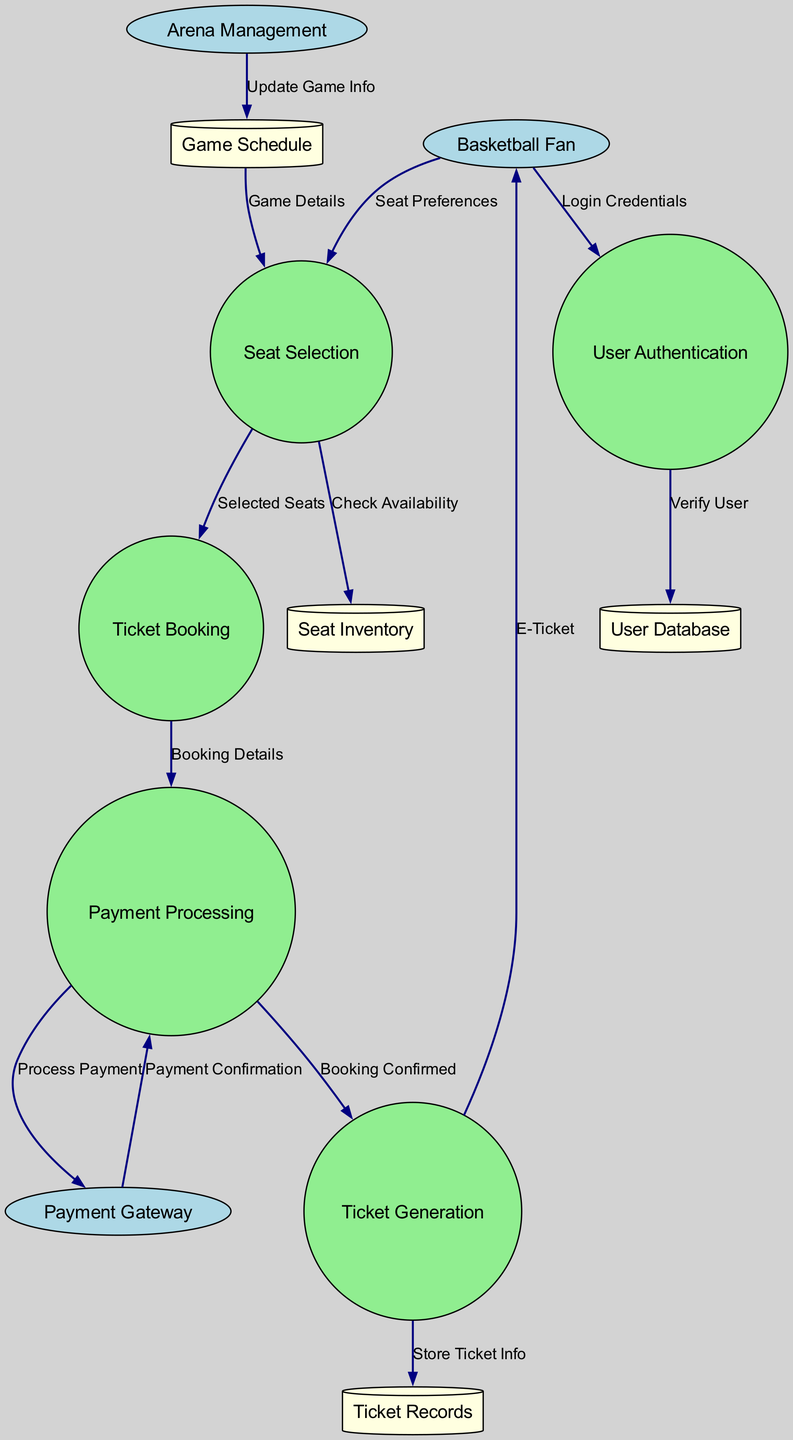What are the external entities in the diagram? The diagram lists three external entities: Basketball Fan, Payment Gateway, and Arena Management. These entities interact with various processes within the system.
Answer: Basketball Fan, Payment Gateway, Arena Management How many data stores are present in the diagram? The diagram shows four data stores: User Database, Seat Inventory, Ticket Records, and Game Schedule. Each stores specific information required for the ticket booking system.
Answer: 4 What is the first process to receive input from the Basketball Fan? The first process that interacts with the Basketball Fan is User Authentication, as it receives the Login Credentials directly from them.
Answer: User Authentication Which process sends the E-Ticket to the Basketball Fan? The Ticket Generation process sends the E-Ticket to the Basketball Fan. This occurs after the ticket has been successfully processed and generated.
Answer: Ticket Generation What data flow follows the Payment Confirmation? The data flow that follows the Payment Confirmation is the Ticket Generation, which is triggered by the Booking Confirmed information sent from Payment Processing.
Answer: Ticket Generation How does Arena Management update game information? Arena Management updates the Game Schedule with new information, which subsequently allows the Seat Selection process to access the latest game details for fans choosing seats.
Answer: Update Game Info What is the last process that occurs in the ticket booking flow? The last process in the ticket booking flow is Ticket Generation, which finalizes the transaction by generating the E-Ticket for the fan after payment is confirmed.
Answer: Ticket Generation What does the Seat Selection process request from the Seat Inventory? The Seat Selection process requests to Check Availability from the Seat Inventory, ensuring that the selected seats are available before proceeding with the booking.
Answer: Check Availability 